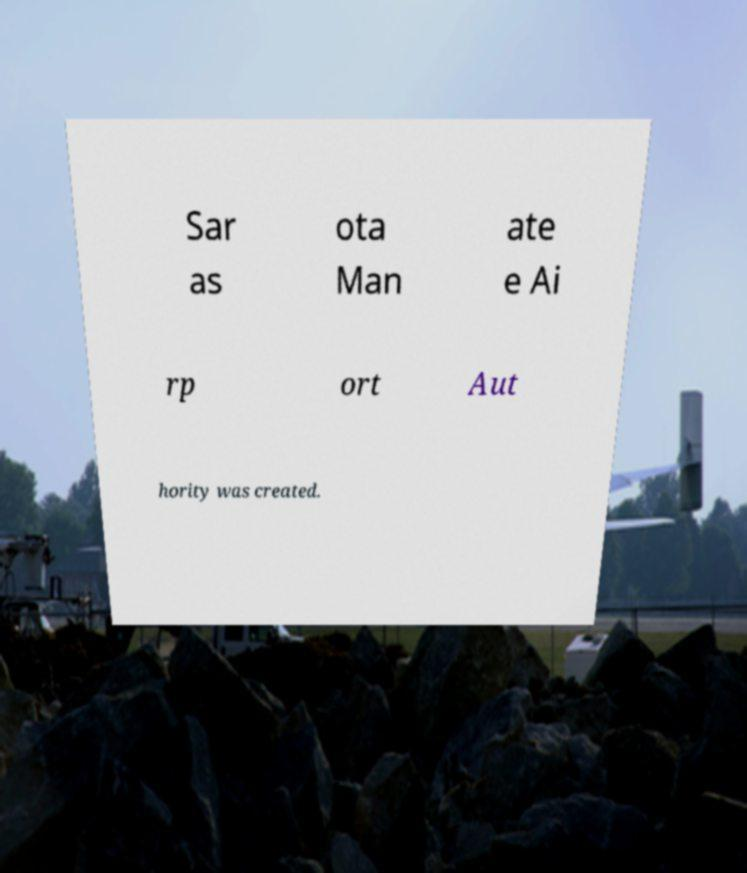What messages or text are displayed in this image? I need them in a readable, typed format. Sar as ota Man ate e Ai rp ort Aut hority was created. 